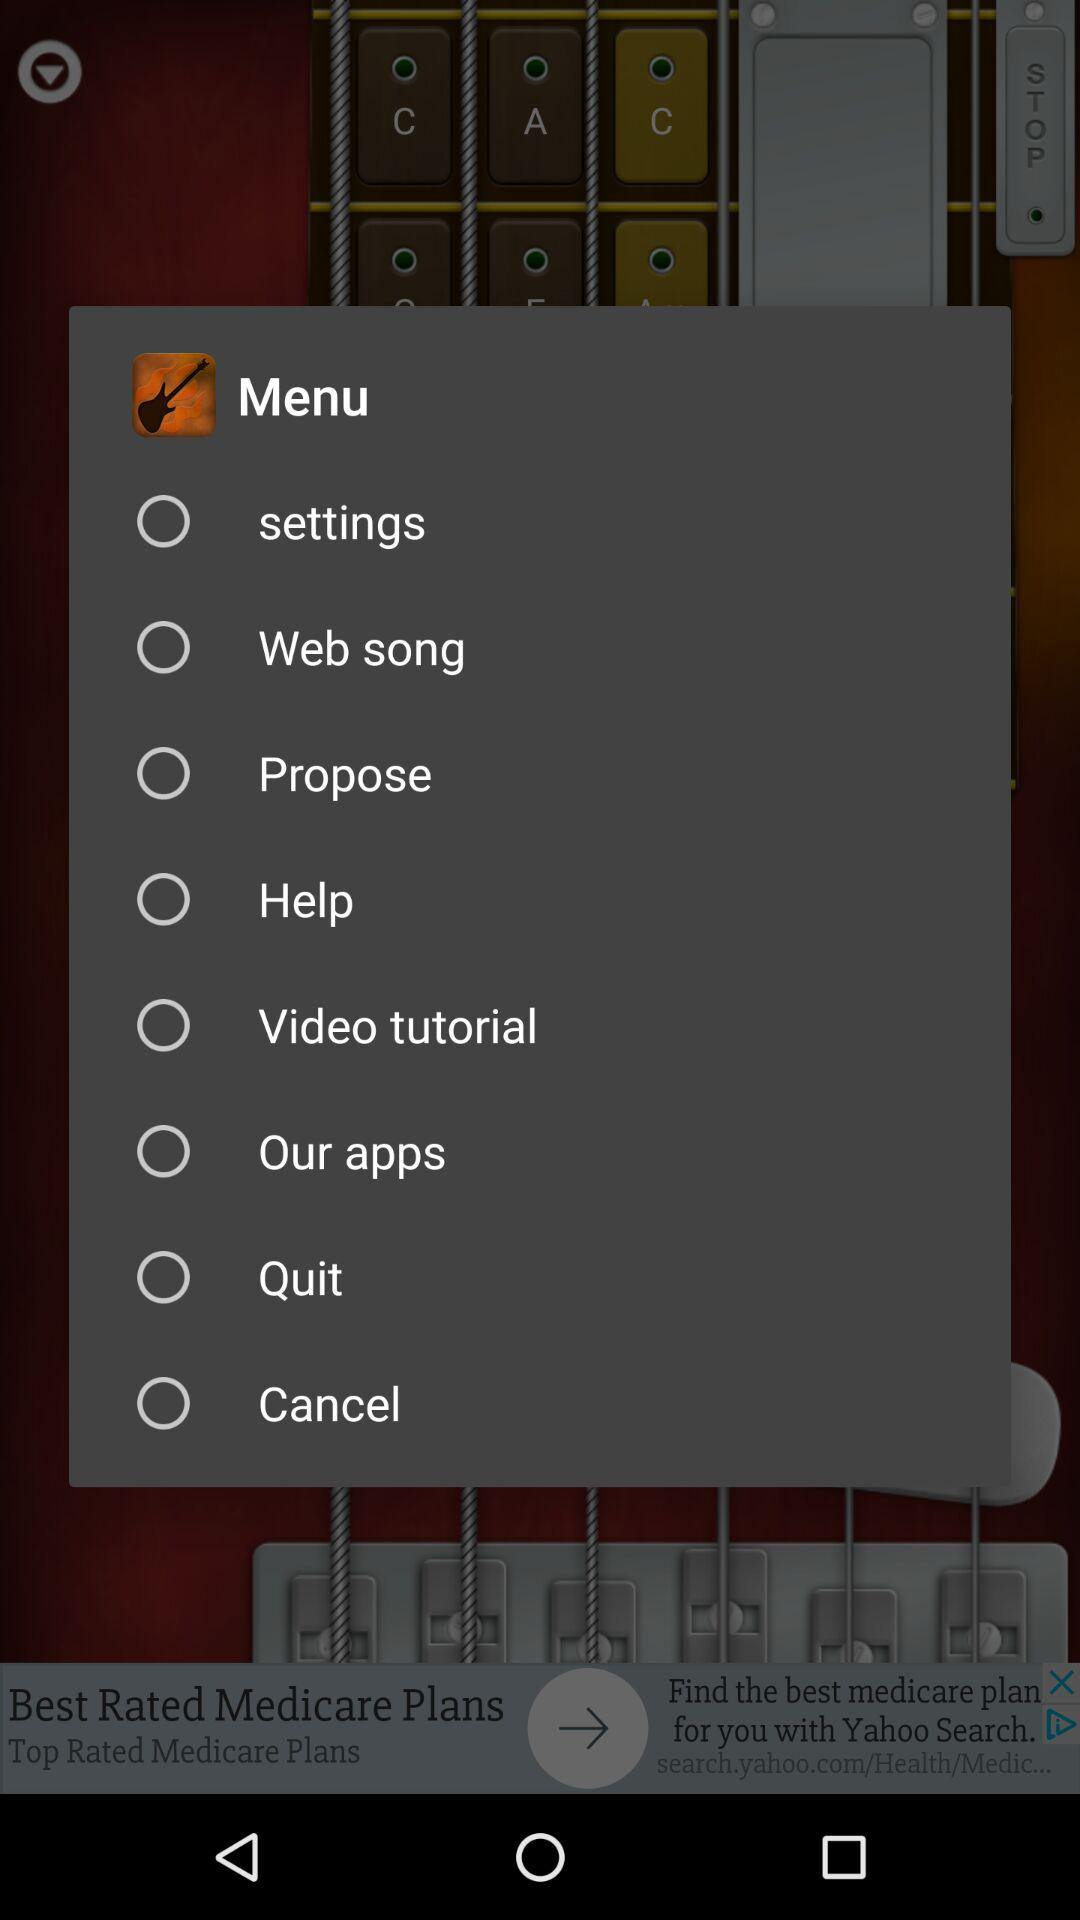What is the status of help? The status is off. 